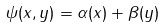<formula> <loc_0><loc_0><loc_500><loc_500>\psi ( x , y ) = \alpha ( x ) + \beta ( y )</formula> 